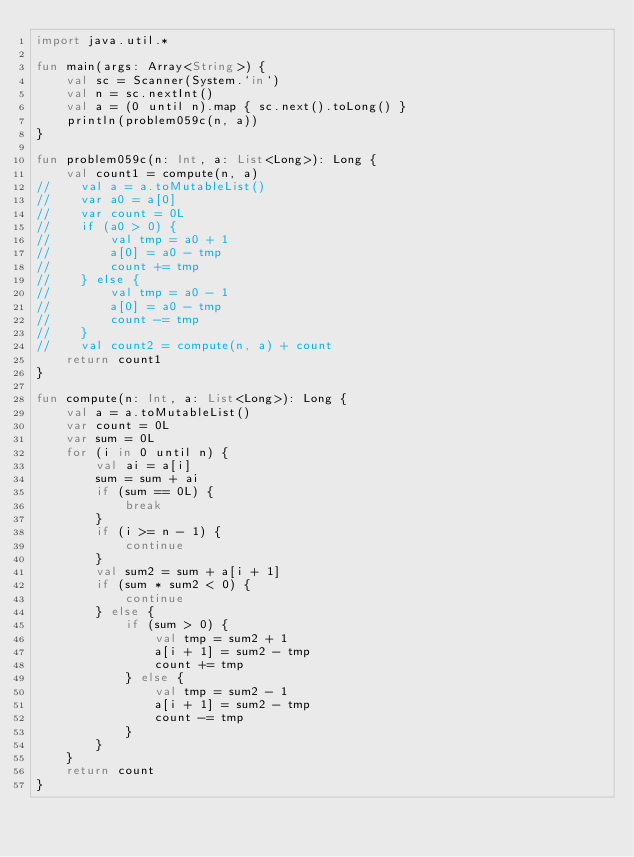Convert code to text. <code><loc_0><loc_0><loc_500><loc_500><_Kotlin_>import java.util.*

fun main(args: Array<String>) {
    val sc = Scanner(System.`in`)
    val n = sc.nextInt()
    val a = (0 until n).map { sc.next().toLong() }
    println(problem059c(n, a))
}

fun problem059c(n: Int, a: List<Long>): Long {
    val count1 = compute(n, a)
//    val a = a.toMutableList()
//    var a0 = a[0]
//    var count = 0L
//    if (a0 > 0) {
//        val tmp = a0 + 1
//        a[0] = a0 - tmp
//        count += tmp
//    } else {
//        val tmp = a0 - 1
//        a[0] = a0 - tmp
//        count -= tmp
//    }
//    val count2 = compute(n, a) + count
    return count1
}

fun compute(n: Int, a: List<Long>): Long {
    val a = a.toMutableList()
    var count = 0L
    var sum = 0L
    for (i in 0 until n) {
        val ai = a[i]
        sum = sum + ai
        if (sum == 0L) {
            break
        }
        if (i >= n - 1) {
            continue
        }
        val sum2 = sum + a[i + 1]
        if (sum * sum2 < 0) {
            continue
        } else {
            if (sum > 0) {
                val tmp = sum2 + 1
                a[i + 1] = sum2 - tmp
                count += tmp
            } else {
                val tmp = sum2 - 1
                a[i + 1] = sum2 - tmp
                count -= tmp
            }
        }
    }
    return count
}</code> 